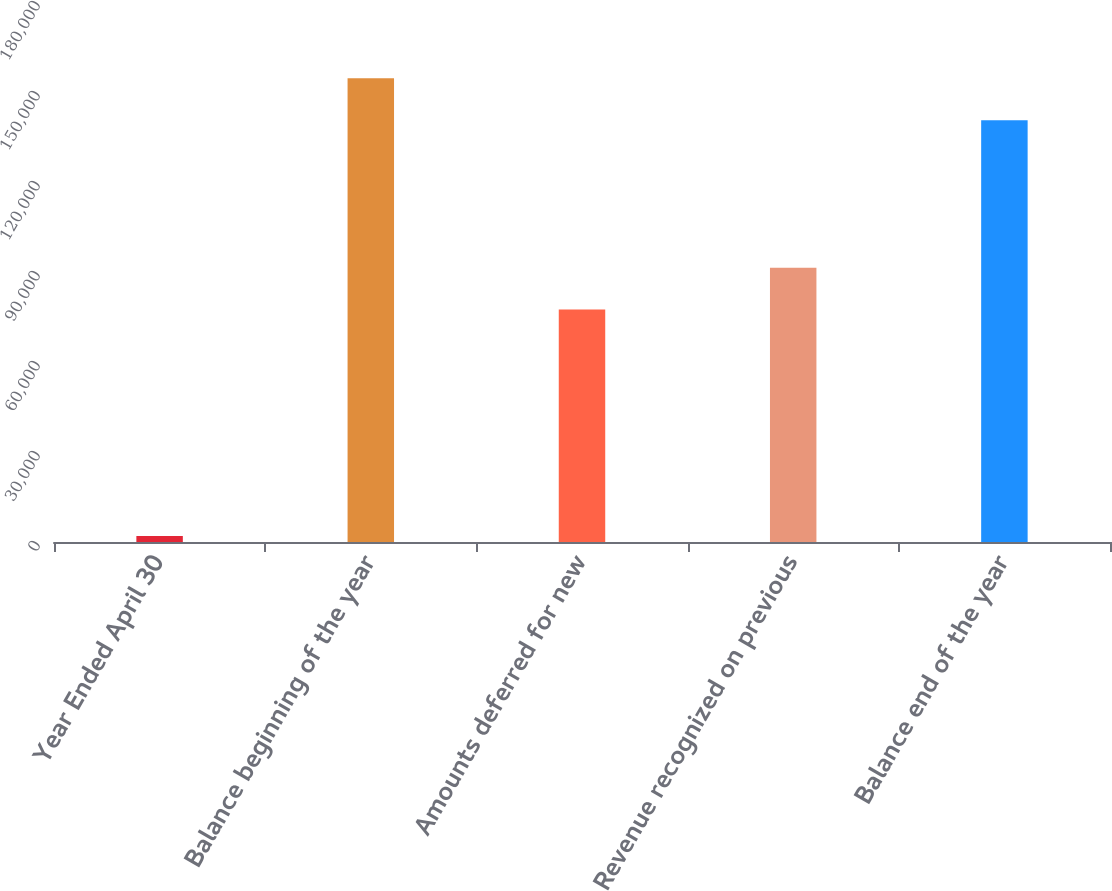Convert chart to OTSL. <chart><loc_0><loc_0><loc_500><loc_500><bar_chart><fcel>Year Ended April 30<fcel>Balance beginning of the year<fcel>Amounts deferred for new<fcel>Revenue recognized on previous<fcel>Balance end of the year<nl><fcel>2011<fcel>154556<fcel>77474<fcel>91427.1<fcel>140603<nl></chart> 